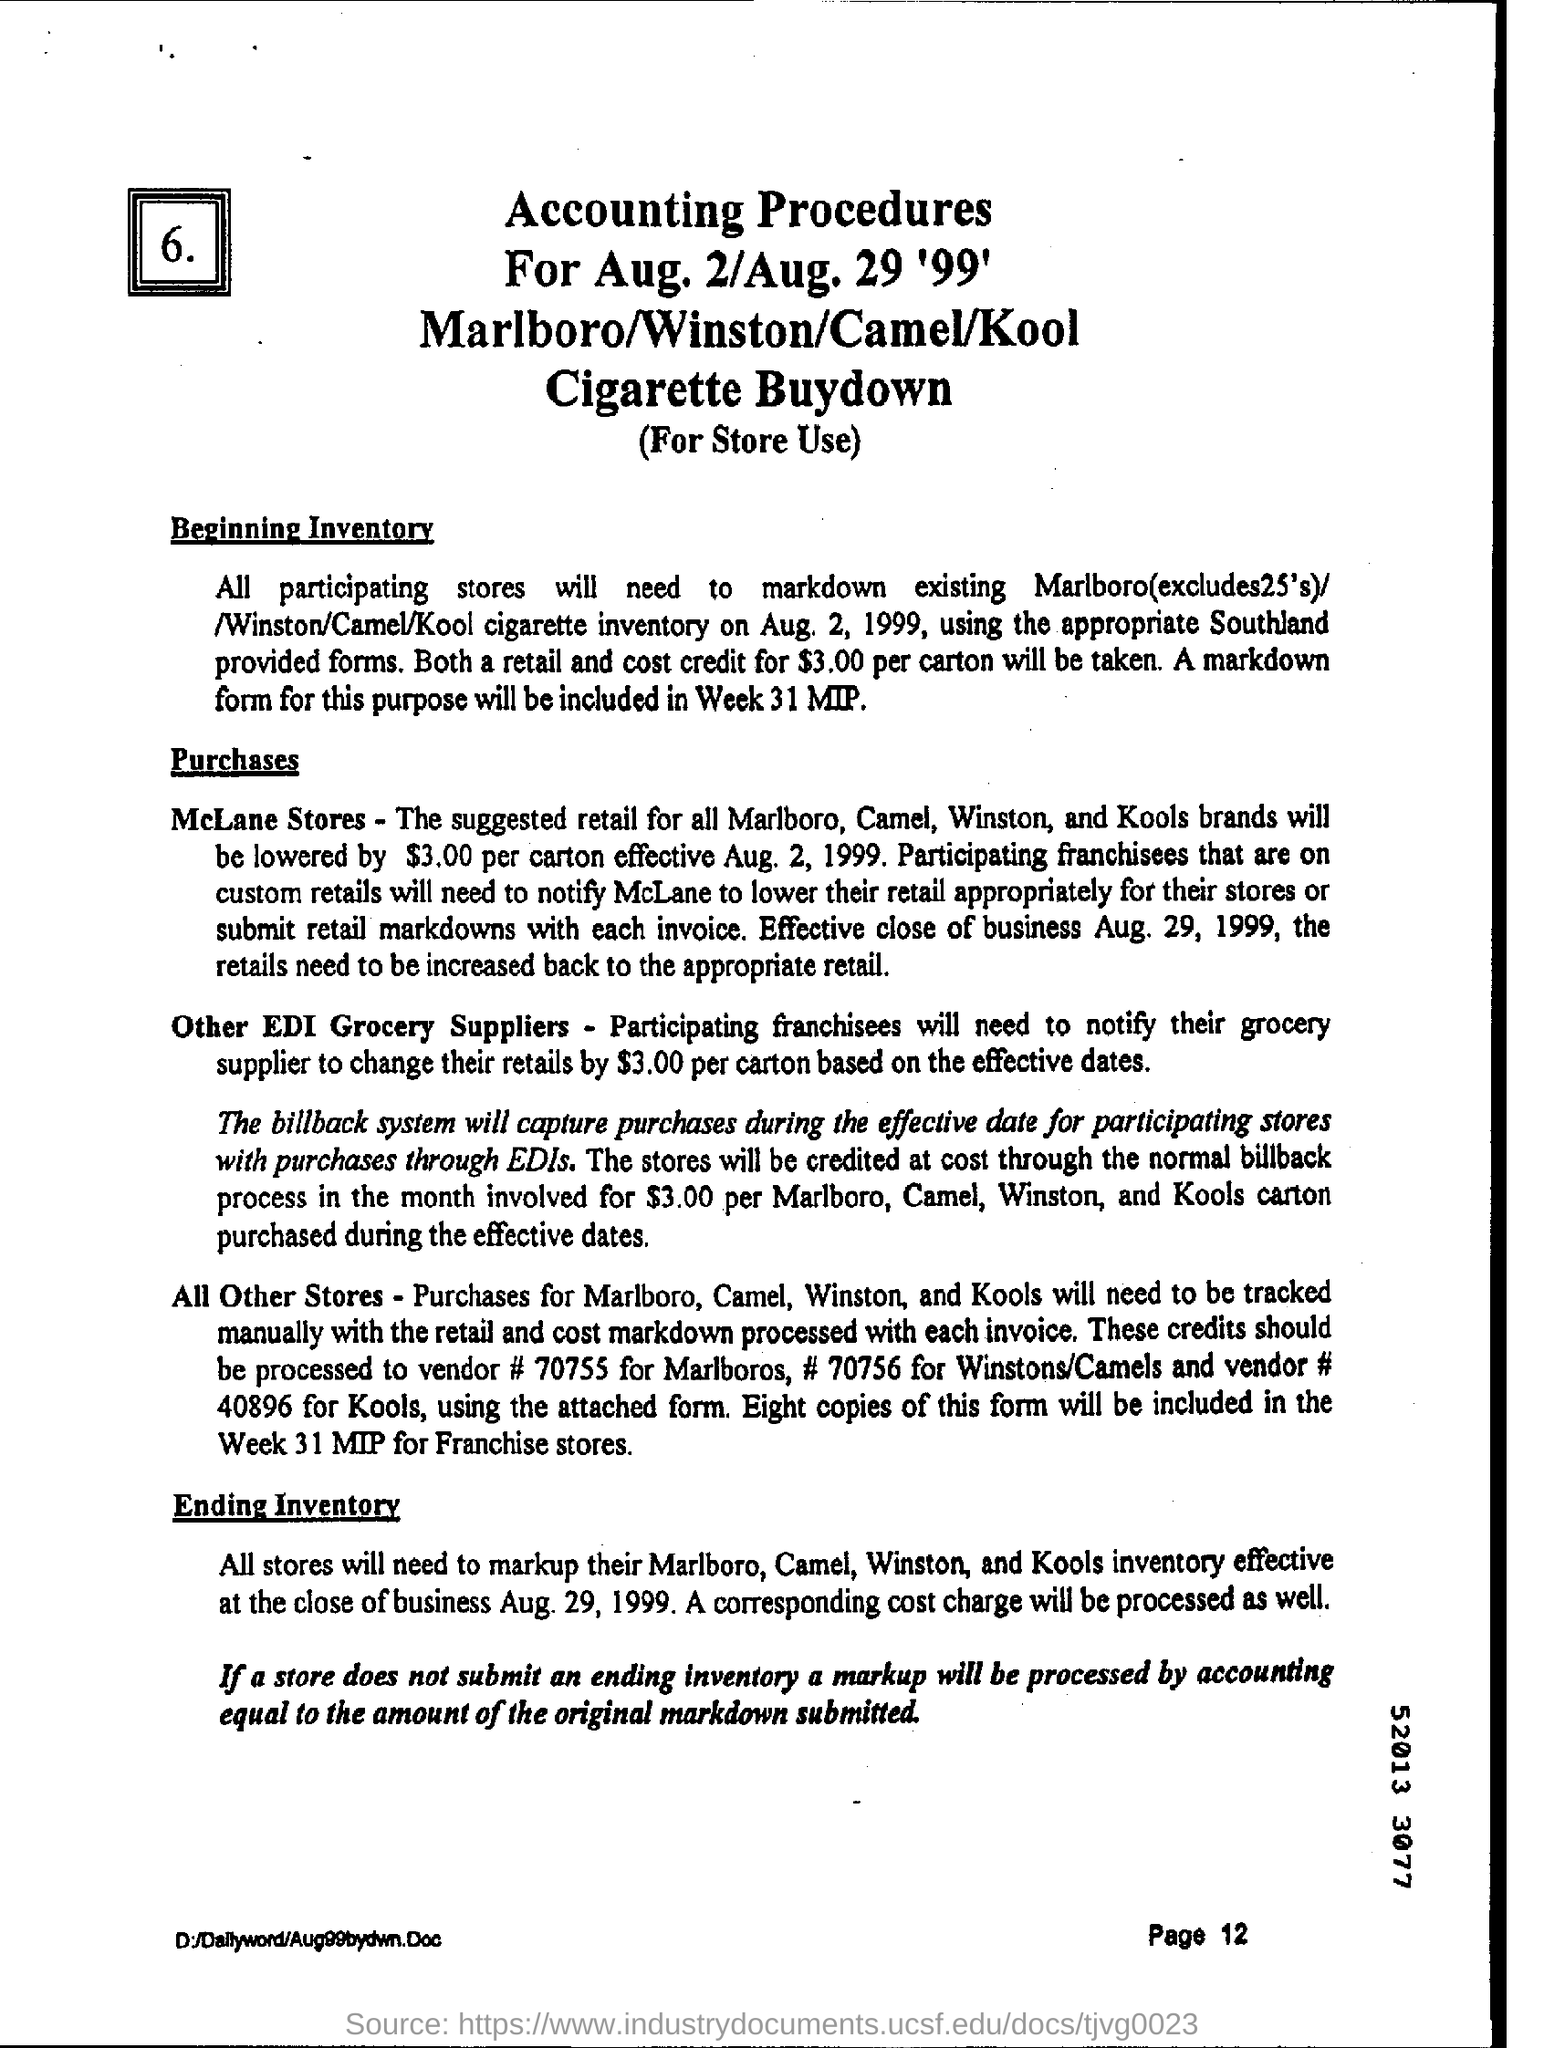What is the title of the document? The title of the document is 'Accounting Procedures for Aug. 2/Aug. 29 '99' relating to a Marlboro/Winston/Camel/Kool Cigarette Buydown. What is the purpose of this document? The purpose of the document is to outline the procedures for a promotional activity where stores are to markdown cigarette inventory for specific brands during a set time period, with details on inventory management and cost adjustments. 